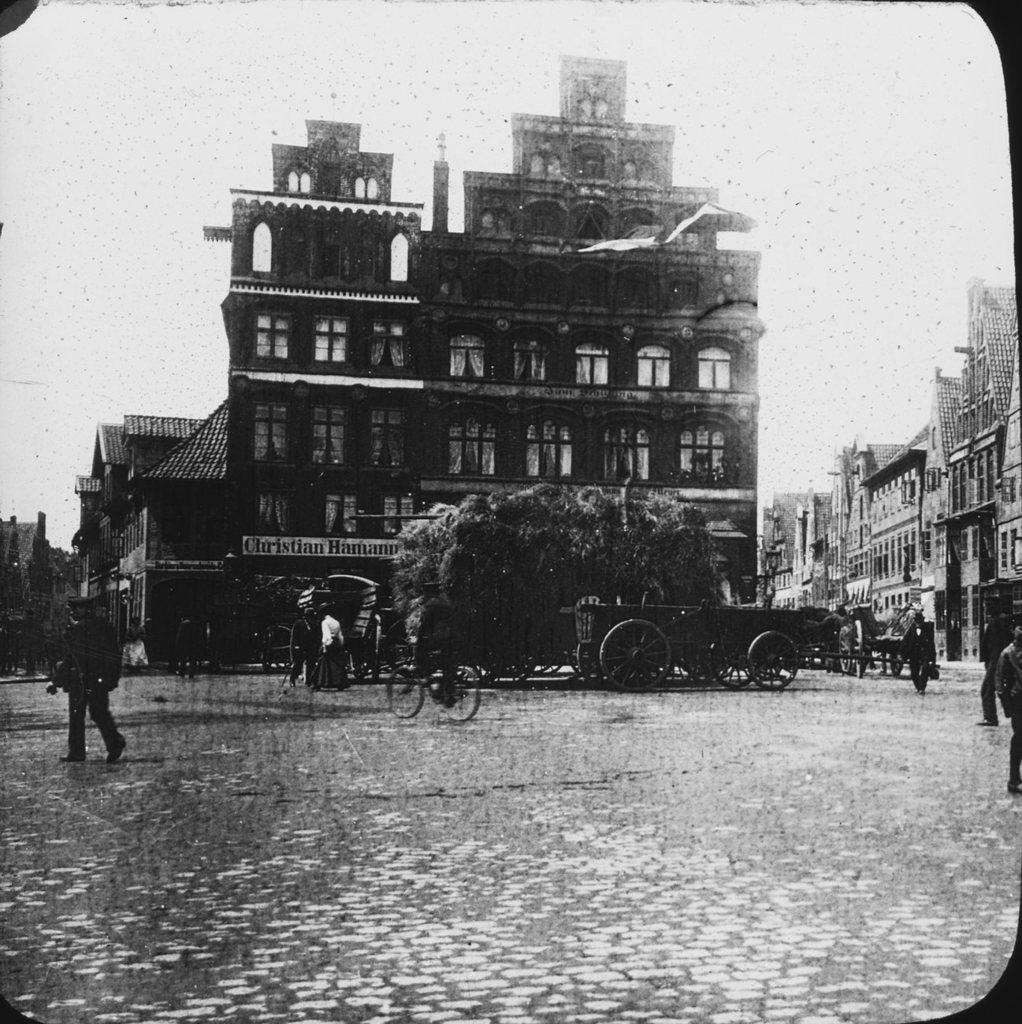What type of structures are present in the image? There are buildings in the image. What type of vehicles are present in the image? There are carts in the image. Are there any living beings in the image? Yes, there are people in the image. What is the color scheme of the image? The image is black and white. What type of rice can be seen being cooked in the image? There is no rice present in the image. How many people are in the crowd in the image? There is no crowd present in the image; there are just people. What type of downtown area is depicted in the image? There is no downtown area depicted in the image; it only shows buildings, carts, and people. 